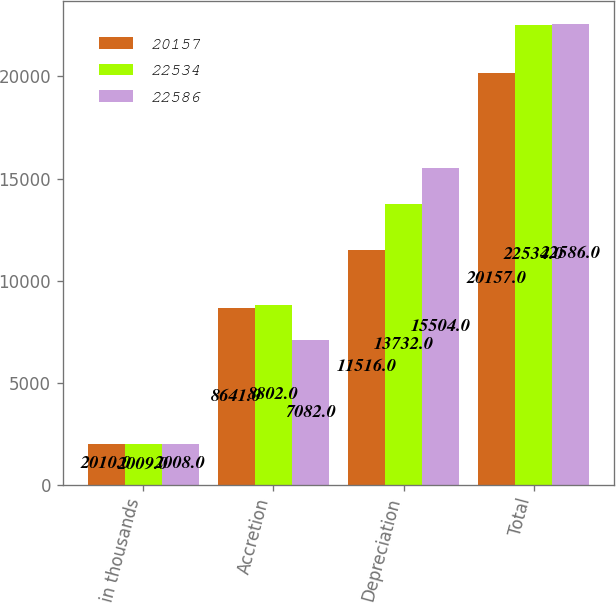<chart> <loc_0><loc_0><loc_500><loc_500><stacked_bar_chart><ecel><fcel>in thousands<fcel>Accretion<fcel>Depreciation<fcel>Total<nl><fcel>20157<fcel>2010<fcel>8641<fcel>11516<fcel>20157<nl><fcel>22534<fcel>2009<fcel>8802<fcel>13732<fcel>22534<nl><fcel>22586<fcel>2008<fcel>7082<fcel>15504<fcel>22586<nl></chart> 